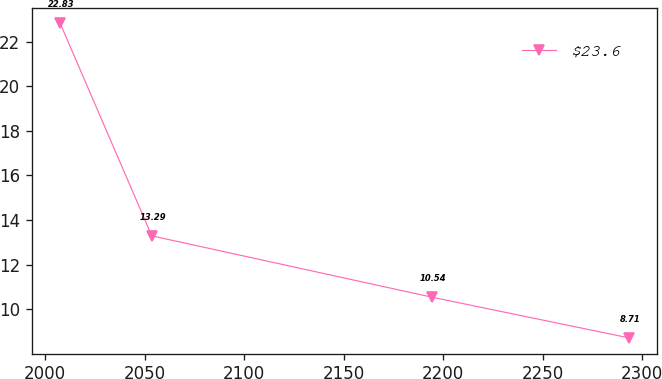Convert chart to OTSL. <chart><loc_0><loc_0><loc_500><loc_500><line_chart><ecel><fcel>$23.6<nl><fcel>2007.52<fcel>22.83<nl><fcel>2053.55<fcel>13.29<nl><fcel>2194.17<fcel>10.54<nl><fcel>2293.38<fcel>8.71<nl></chart> 